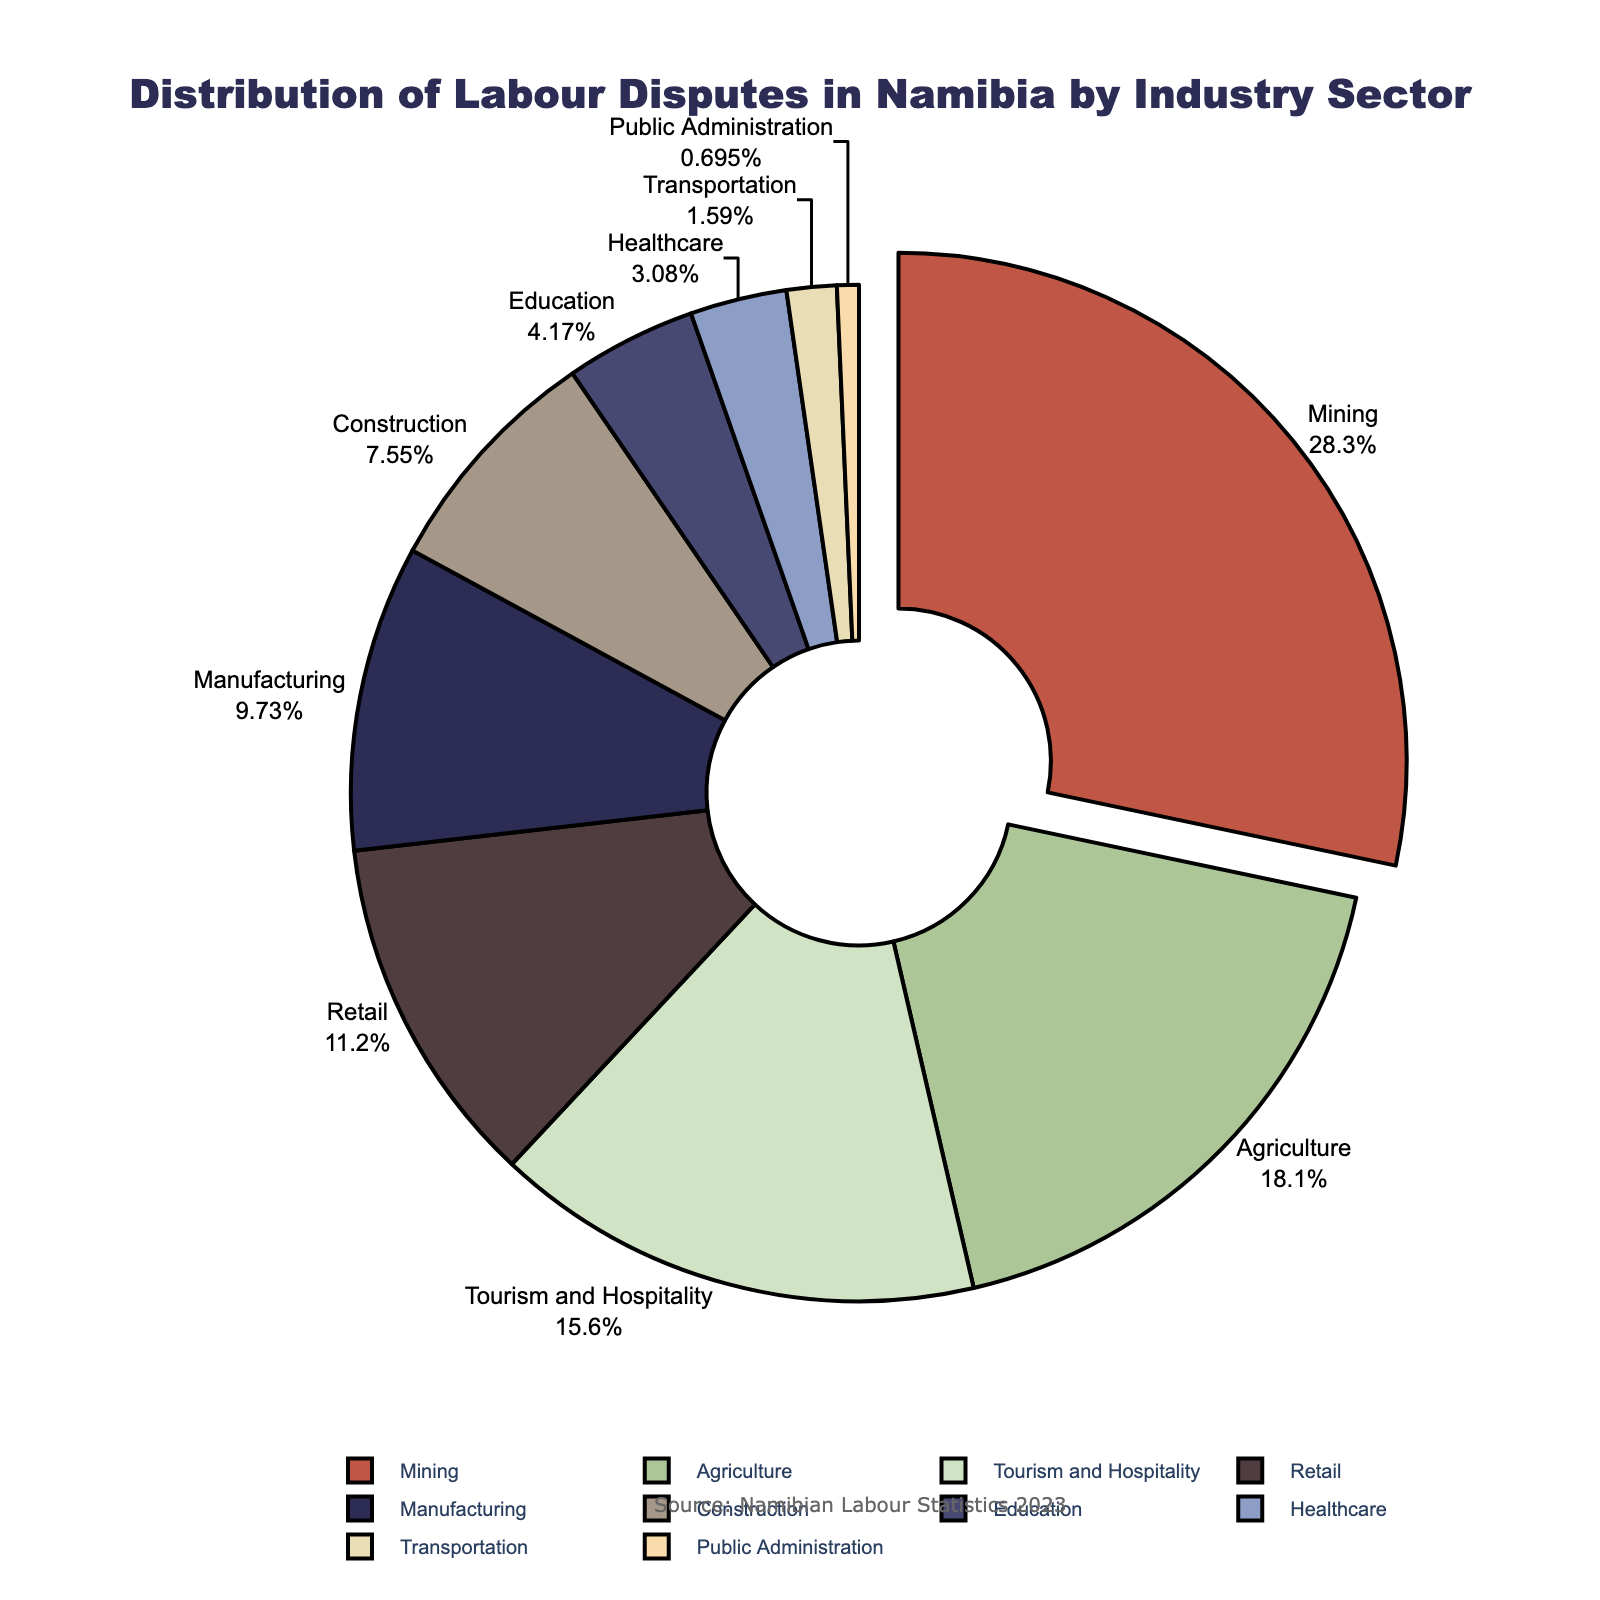What industry sector has the highest percentage of labour disputes? The sector with the highest percentage of labour disputes is marked by a segment pulled out from the pie chart and labeled with the highest percentage.
Answer: Mining Which two sectors combined have a larger share of disputes than the mining sector? Inspect sectors whose combined percentage surpasses the mining sector's 28.5%. Agriculture (18.2%) and Tourism and Hospitality (15.7%) add up to 33.9%, which is greater than 28.5%.
Answer: Agriculture and Tourism and Hospitality What is the percentage difference between disputes in the Mining sector and the Retail sector? Subtract the percentage of labour disputes in the Retail sector (11.3%) from that in the Mining sector (28.5%). The difference is 28.5% - 11.3%.
Answer: 17.2% Which sector has a higher percentage of labour disputes: Manufacturing or Construction? Compare the percentages of Manufacturing (9.8%) and Construction (7.6%). Manufacturing has a higher percentage than Construction.
Answer: Manufacturing How many sectors have a percentage of labour disputes below 5%? Count the sectors with percentages lower than 5%. These are Education (4.2%), Healthcare (3.1%), Transportation (1.6%), and Public Administration (0.7%).
Answer: 4 What is the average percentage of labour disputes in the Healthcare, Education, and Transportation sectors? Sum the percentages of these sectors: Healthcare (3.1%), Education (4.2%), and Transportation (1.6%), then divide by the number of sectors (3). The average is (3.1 + 4.2 + 1.6) / 3.
Answer: 2.97% What is the total percentage of labour disputes for sectors with less than 10% disputes each? Sum the percentages of sectors with less than 10% disputes: Manufacturing (9.8%), Construction (7.6%), Education (4.2%), Healthcare (3.1%), Transportation (1.6%), and Public Administration (0.7%). The total is 9.8% + 7.6% + 4.2% + 3.1% + 1.6% + 0.7%.
Answer: 27% Which sector has the smallest percentage of labour disputes? The smallest percentage on the pie chart is labeled accordingly. The Public Administration sector has the smallest share at 0.7%.
Answer: Public Administration What is the combined percentage of disputes in the Agriculture and Retail sectors? Add the percentages of labour disputes in Agriculture (18.2%) and Retail (11.3%). The combined percentage is 18.2% + 11.3%.
Answer: 29.5% What percentage of labour disputes do the top three sectors cover? Sum the percentages of the top three sectors: Mining (28.5%), Agriculture (18.2%), and Tourism and Hospitality (15.7%). The total percentage is 28.5% + 18.2% + 15.7%.
Answer: 62.4% 